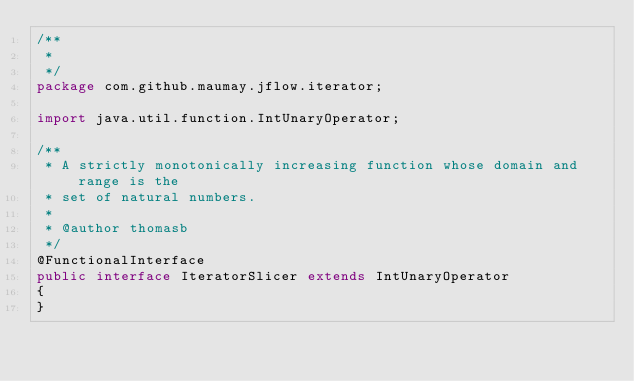<code> <loc_0><loc_0><loc_500><loc_500><_Java_>/**
 * 
 */
package com.github.maumay.jflow.iterator;

import java.util.function.IntUnaryOperator;

/**
 * A strictly monotonically increasing function whose domain and range is the
 * set of natural numbers.
 * 
 * @author thomasb
 */
@FunctionalInterface
public interface IteratorSlicer extends IntUnaryOperator
{
}
</code> 